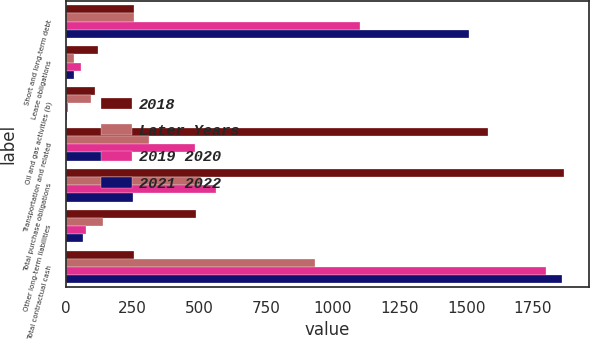Convert chart. <chart><loc_0><loc_0><loc_500><loc_500><stacked_bar_chart><ecel><fcel>Short and long-term debt<fcel>Lease obligations<fcel>Oil and gas activities (b)<fcel>Transportation and related<fcel>Total purchase obligations<fcel>Other long-term liabilities<fcel>Total contractual cash<nl><fcel>2018<fcel>254<fcel>119<fcel>108<fcel>1581<fcel>1867<fcel>486<fcel>254<nl><fcel>Later Years<fcel>256<fcel>29<fcel>94<fcel>313<fcel>506<fcel>141<fcel>932<nl><fcel>2019 2020<fcel>1103<fcel>55<fcel>8<fcel>483<fcel>563<fcel>77<fcel>1798<nl><fcel>2021 2022<fcel>1512<fcel>31<fcel>4<fcel>241<fcel>252<fcel>63<fcel>1858<nl></chart> 